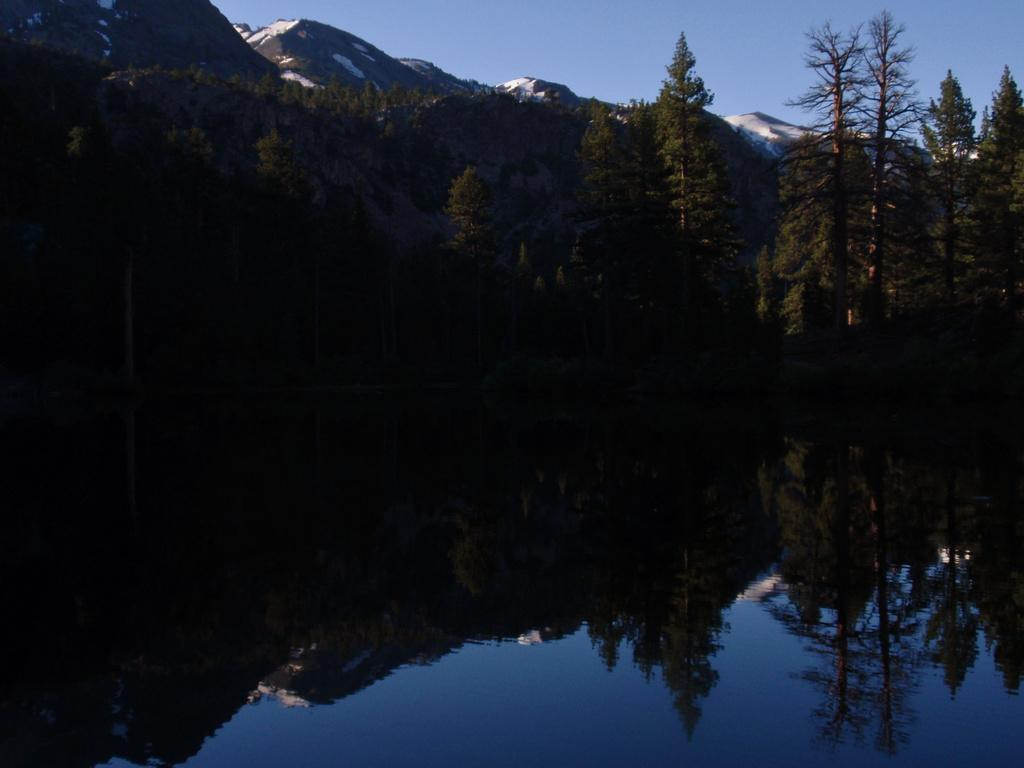What is the main feature of the image? The main feature of the image is water. What can be seen in the background of the image? There is a mountain and trees in the background of the image. What is reflected on the water's surface? The reflection of trees is visible on the water. What is the color of the sky in the image? The sky is blue in color. How is the moon affecting the water in the image? The moon is not visible in the image, so it cannot be affecting the water. 